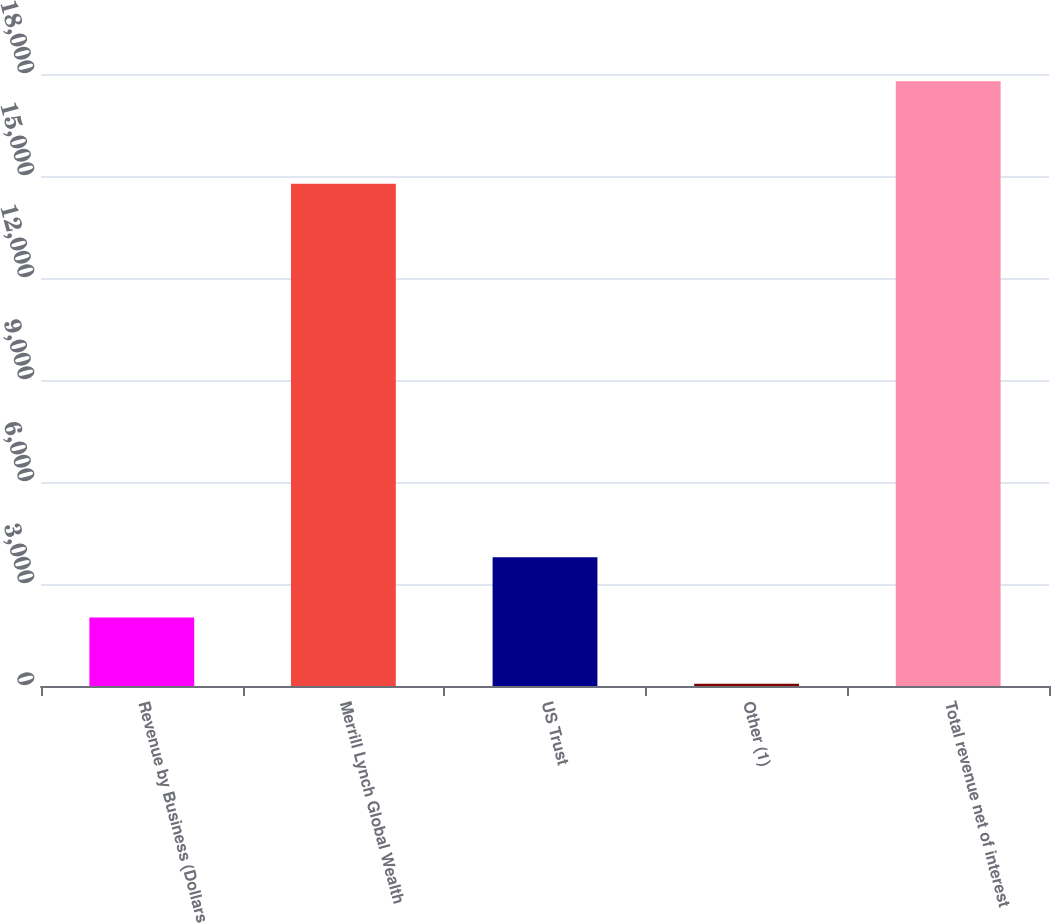Convert chart. <chart><loc_0><loc_0><loc_500><loc_500><bar_chart><fcel>Revenue by Business (Dollars<fcel>Merrill Lynch Global Wealth<fcel>US Trust<fcel>Other (1)<fcel>Total revenue net of interest<nl><fcel>2013<fcel>14771<fcel>3785.4<fcel>66<fcel>17790<nl></chart> 